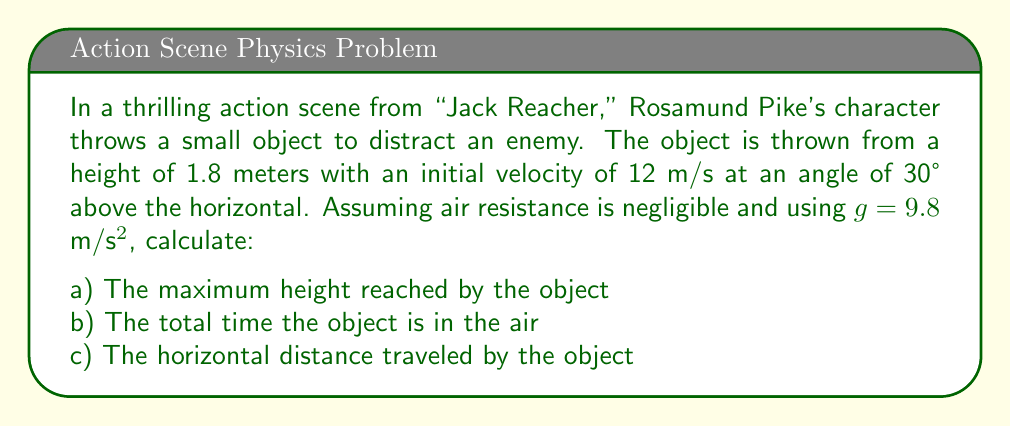Teach me how to tackle this problem. Let's break this down step by step:

1) First, we need to determine the initial vertical and horizontal components of velocity:
   $v_{0x} = v_0 \cos \theta = 12 \cos 30° = 10.39$ m/s
   $v_{0y} = v_0 \sin \theta = 12 \sin 30° = 6$ m/s

2) For part a), we can use the equation:
   $h_{max} = h_0 + \frac{v_{0y}^2}{2g}$
   Where $h_0$ is the initial height.
   
   $h_{max} = 1.8 + \frac{6^2}{2(9.8)} = 1.8 + 1.84 = 3.64$ m

3) For part b), we need to calculate the time to reach the maximum height and double it:
   $t_{up} = \frac{v_{0y}}{g} = \frac{6}{9.8} = 0.61$ s
   
   Total time = $2t_{up} = 2(0.61) = 1.22$ s

4) For part c), we use the horizontal distance formula:
   $d = v_{0x} \cdot t_{total} = 10.39 \cdot 1.22 = 12.68$ m
Answer: a) Maximum height: 3.64 m
b) Total time in air: 1.22 s
c) Horizontal distance: 12.68 m 